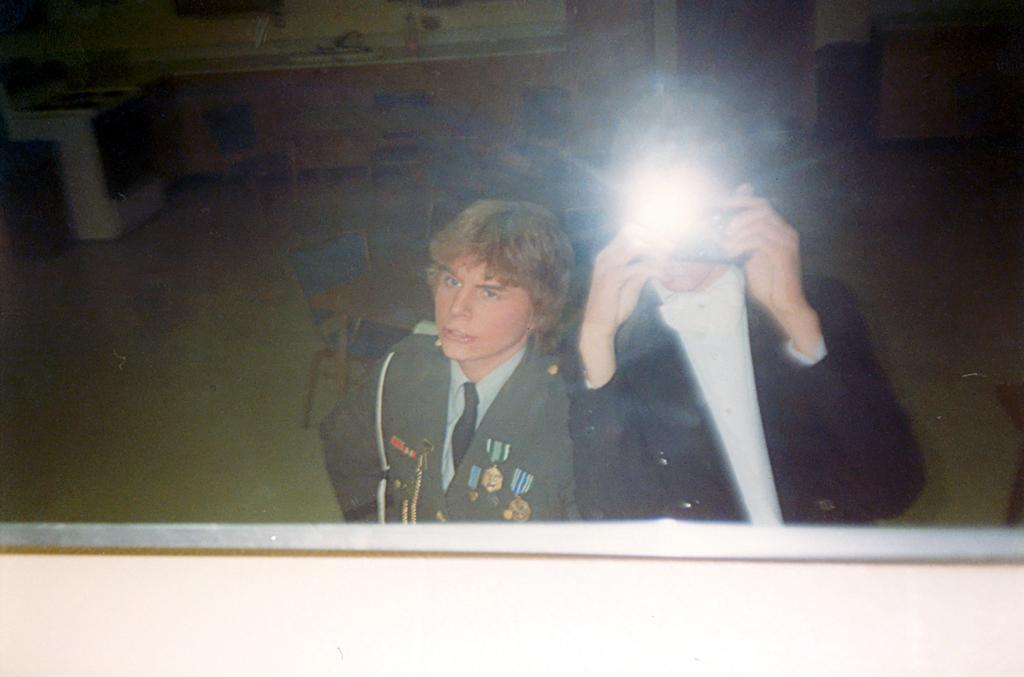Can you describe this image briefly? In the image there is a person in black dress holding camera and a boy standing beside him in sheriff costume, they are taking selfie in the mirror and in the back there are some things in front of the wall. 